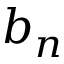<formula> <loc_0><loc_0><loc_500><loc_500>b _ { n }</formula> 